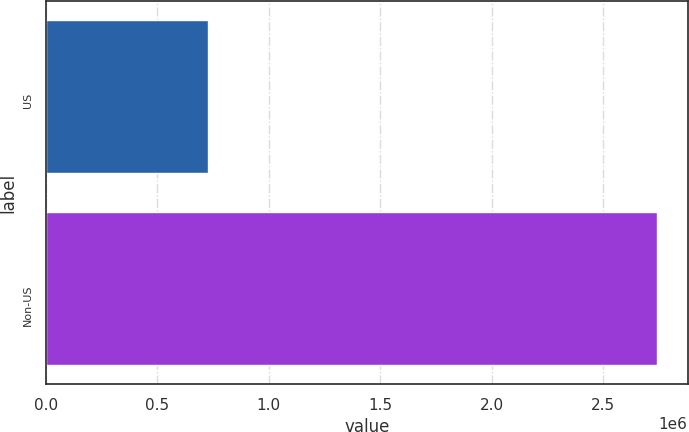Convert chart. <chart><loc_0><loc_0><loc_500><loc_500><bar_chart><fcel>US<fcel>Non-US<nl><fcel>725000<fcel>2.741e+06<nl></chart> 